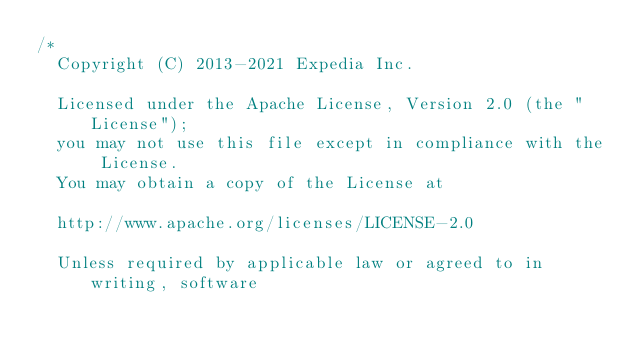<code> <loc_0><loc_0><loc_500><loc_500><_Java_>/*
  Copyright (C) 2013-2021 Expedia Inc.

  Licensed under the Apache License, Version 2.0 (the "License");
  you may not use this file except in compliance with the License.
  You may obtain a copy of the License at

  http://www.apache.org/licenses/LICENSE-2.0

  Unless required by applicable law or agreed to in writing, software</code> 